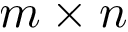<formula> <loc_0><loc_0><loc_500><loc_500>m \times n</formula> 